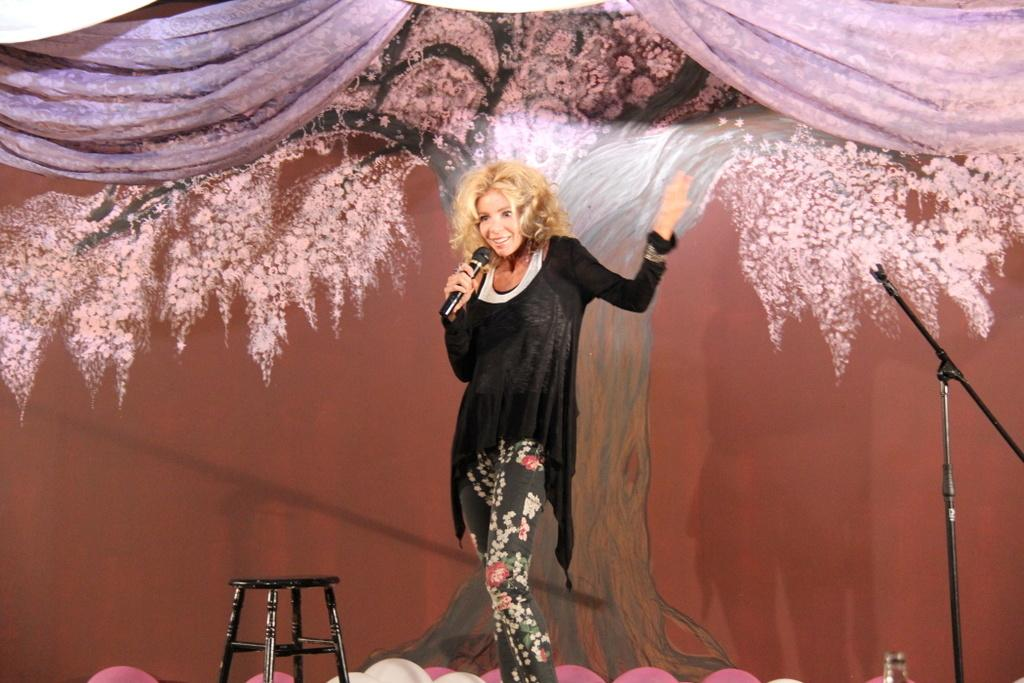Who is the main subject in the image? There is a woman in the image. What is the woman wearing? The woman is wearing a black dress. Where is the woman located in the image? The woman is standing on a stage. What is the woman holding in the image? The woman is holding a microphone. What can be seen behind the woman in the image? There is a wall behind the woman. What type of toothbrush is the woman using in the image? There is no toothbrush present in the image; the woman is holding a microphone. What is the woman painting on the canvas in the image? There is no canvas present in the image; the woman is standing on a stage. 